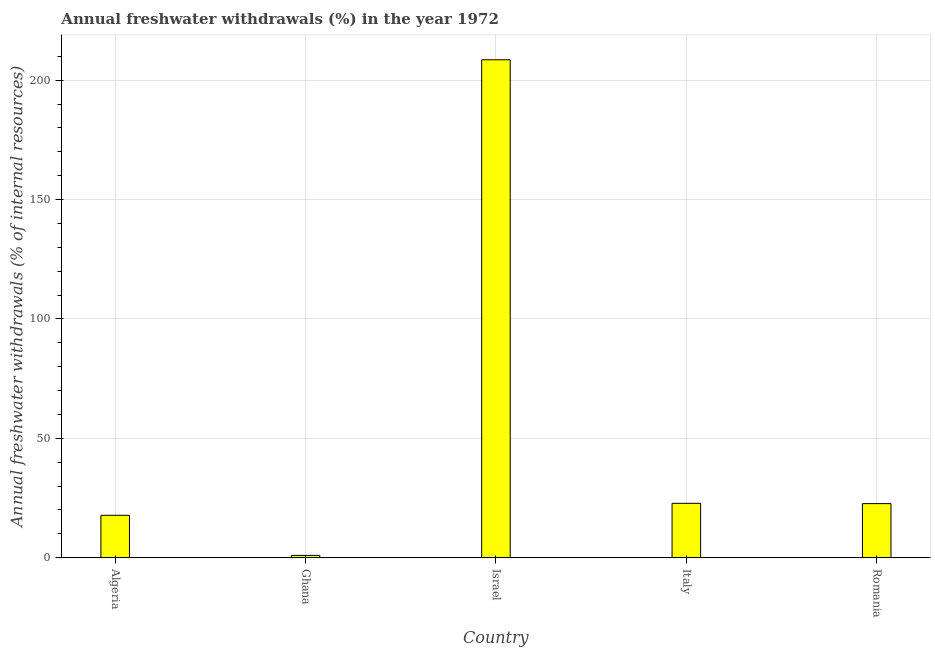Does the graph contain any zero values?
Keep it short and to the point. No. Does the graph contain grids?
Make the answer very short. Yes. What is the title of the graph?
Offer a terse response. Annual freshwater withdrawals (%) in the year 1972. What is the label or title of the Y-axis?
Provide a succinct answer. Annual freshwater withdrawals (% of internal resources). What is the annual freshwater withdrawals in Israel?
Make the answer very short. 208.53. Across all countries, what is the maximum annual freshwater withdrawals?
Give a very brief answer. 208.53. Across all countries, what is the minimum annual freshwater withdrawals?
Offer a very short reply. 0.99. In which country was the annual freshwater withdrawals minimum?
Offer a terse response. Ghana. What is the sum of the annual freshwater withdrawals?
Provide a succinct answer. 272.77. What is the difference between the annual freshwater withdrawals in Ghana and Romania?
Ensure brevity in your answer.  -21.68. What is the average annual freshwater withdrawals per country?
Offer a terse response. 54.55. What is the median annual freshwater withdrawals?
Offer a very short reply. 22.67. In how many countries, is the annual freshwater withdrawals greater than 200 %?
Your answer should be compact. 1. What is the ratio of the annual freshwater withdrawals in Italy to that in Romania?
Give a very brief answer. 1. Is the annual freshwater withdrawals in Ghana less than that in Israel?
Provide a succinct answer. Yes. Is the difference between the annual freshwater withdrawals in Algeria and Romania greater than the difference between any two countries?
Provide a short and direct response. No. What is the difference between the highest and the second highest annual freshwater withdrawals?
Give a very brief answer. 185.74. What is the difference between the highest and the lowest annual freshwater withdrawals?
Ensure brevity in your answer.  207.54. In how many countries, is the annual freshwater withdrawals greater than the average annual freshwater withdrawals taken over all countries?
Provide a short and direct response. 1. Are the values on the major ticks of Y-axis written in scientific E-notation?
Provide a short and direct response. No. What is the Annual freshwater withdrawals (% of internal resources) in Algeria?
Make the answer very short. 17.78. What is the Annual freshwater withdrawals (% of internal resources) of Ghana?
Provide a short and direct response. 0.99. What is the Annual freshwater withdrawals (% of internal resources) of Israel?
Your response must be concise. 208.53. What is the Annual freshwater withdrawals (% of internal resources) in Italy?
Offer a terse response. 22.79. What is the Annual freshwater withdrawals (% of internal resources) in Romania?
Ensure brevity in your answer.  22.67. What is the difference between the Annual freshwater withdrawals (% of internal resources) in Algeria and Ghana?
Give a very brief answer. 16.79. What is the difference between the Annual freshwater withdrawals (% of internal resources) in Algeria and Israel?
Make the answer very short. -190.76. What is the difference between the Annual freshwater withdrawals (% of internal resources) in Algeria and Italy?
Offer a very short reply. -5.02. What is the difference between the Annual freshwater withdrawals (% of internal resources) in Algeria and Romania?
Make the answer very short. -4.89. What is the difference between the Annual freshwater withdrawals (% of internal resources) in Ghana and Israel?
Your answer should be very brief. -207.54. What is the difference between the Annual freshwater withdrawals (% of internal resources) in Ghana and Italy?
Offer a very short reply. -21.8. What is the difference between the Annual freshwater withdrawals (% of internal resources) in Ghana and Romania?
Your answer should be compact. -21.68. What is the difference between the Annual freshwater withdrawals (% of internal resources) in Israel and Italy?
Your answer should be compact. 185.74. What is the difference between the Annual freshwater withdrawals (% of internal resources) in Israel and Romania?
Your answer should be compact. 185.86. What is the difference between the Annual freshwater withdrawals (% of internal resources) in Italy and Romania?
Ensure brevity in your answer.  0.12. What is the ratio of the Annual freshwater withdrawals (% of internal resources) in Algeria to that in Ghana?
Ensure brevity in your answer.  17.96. What is the ratio of the Annual freshwater withdrawals (% of internal resources) in Algeria to that in Israel?
Give a very brief answer. 0.09. What is the ratio of the Annual freshwater withdrawals (% of internal resources) in Algeria to that in Italy?
Offer a very short reply. 0.78. What is the ratio of the Annual freshwater withdrawals (% of internal resources) in Algeria to that in Romania?
Make the answer very short. 0.78. What is the ratio of the Annual freshwater withdrawals (% of internal resources) in Ghana to that in Israel?
Make the answer very short. 0.01. What is the ratio of the Annual freshwater withdrawals (% of internal resources) in Ghana to that in Italy?
Your answer should be very brief. 0.04. What is the ratio of the Annual freshwater withdrawals (% of internal resources) in Ghana to that in Romania?
Your response must be concise. 0.04. What is the ratio of the Annual freshwater withdrawals (% of internal resources) in Israel to that in Italy?
Ensure brevity in your answer.  9.15. What is the ratio of the Annual freshwater withdrawals (% of internal resources) in Israel to that in Romania?
Offer a very short reply. 9.2. 